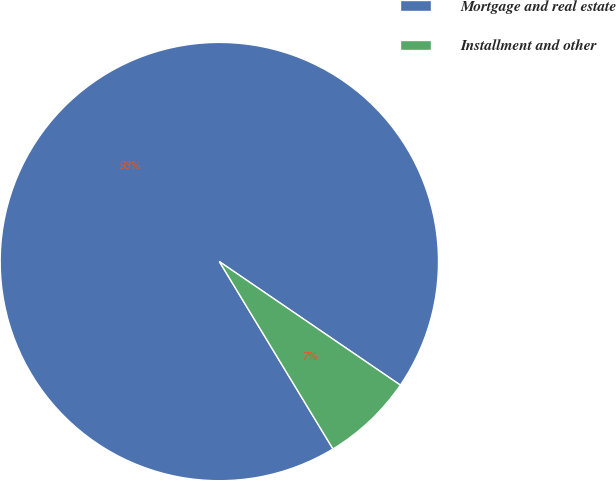<chart> <loc_0><loc_0><loc_500><loc_500><pie_chart><fcel>Mortgage and real estate<fcel>Installment and other<nl><fcel>93.21%<fcel>6.79%<nl></chart> 